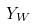Convert formula to latex. <formula><loc_0><loc_0><loc_500><loc_500>Y _ { W }</formula> 